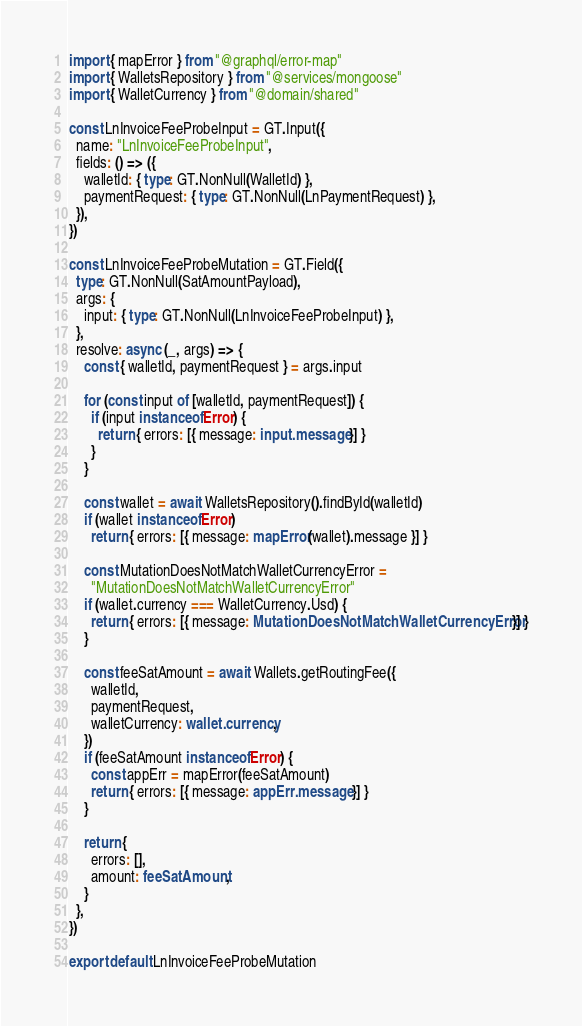<code> <loc_0><loc_0><loc_500><loc_500><_TypeScript_>import { mapError } from "@graphql/error-map"
import { WalletsRepository } from "@services/mongoose"
import { WalletCurrency } from "@domain/shared"

const LnInvoiceFeeProbeInput = GT.Input({
  name: "LnInvoiceFeeProbeInput",
  fields: () => ({
    walletId: { type: GT.NonNull(WalletId) },
    paymentRequest: { type: GT.NonNull(LnPaymentRequest) },
  }),
})

const LnInvoiceFeeProbeMutation = GT.Field({
  type: GT.NonNull(SatAmountPayload),
  args: {
    input: { type: GT.NonNull(LnInvoiceFeeProbeInput) },
  },
  resolve: async (_, args) => {
    const { walletId, paymentRequest } = args.input

    for (const input of [walletId, paymentRequest]) {
      if (input instanceof Error) {
        return { errors: [{ message: input.message }] }
      }
    }

    const wallet = await WalletsRepository().findById(walletId)
    if (wallet instanceof Error)
      return { errors: [{ message: mapError(wallet).message }] }

    const MutationDoesNotMatchWalletCurrencyError =
      "MutationDoesNotMatchWalletCurrencyError"
    if (wallet.currency === WalletCurrency.Usd) {
      return { errors: [{ message: MutationDoesNotMatchWalletCurrencyError }] }
    }

    const feeSatAmount = await Wallets.getRoutingFee({
      walletId,
      paymentRequest,
      walletCurrency: wallet.currency,
    })
    if (feeSatAmount instanceof Error) {
      const appErr = mapError(feeSatAmount)
      return { errors: [{ message: appErr.message }] }
    }

    return {
      errors: [],
      amount: feeSatAmount,
    }
  },
})

export default LnInvoiceFeeProbeMutation
</code> 